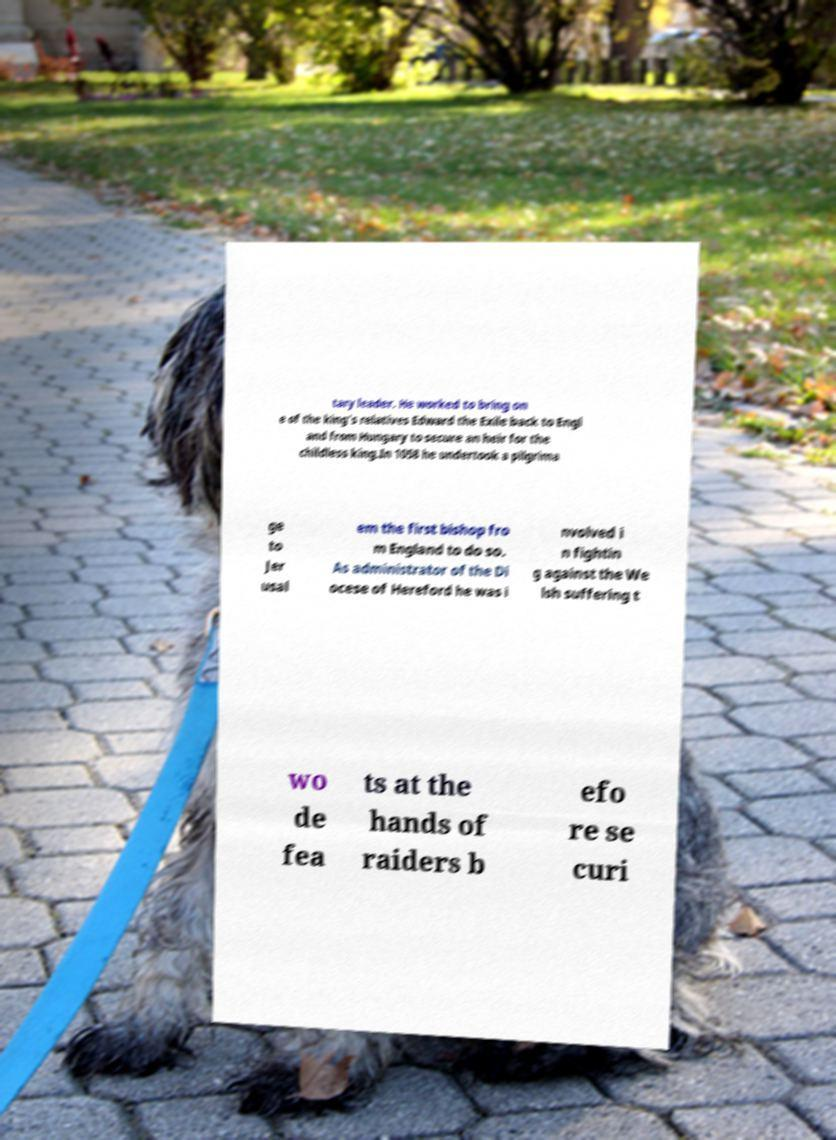There's text embedded in this image that I need extracted. Can you transcribe it verbatim? tary leader. He worked to bring on e of the king's relatives Edward the Exile back to Engl and from Hungary to secure an heir for the childless king.In 1058 he undertook a pilgrima ge to Jer usal em the first bishop fro m England to do so. As administrator of the Di ocese of Hereford he was i nvolved i n fightin g against the We lsh suffering t wo de fea ts at the hands of raiders b efo re se curi 